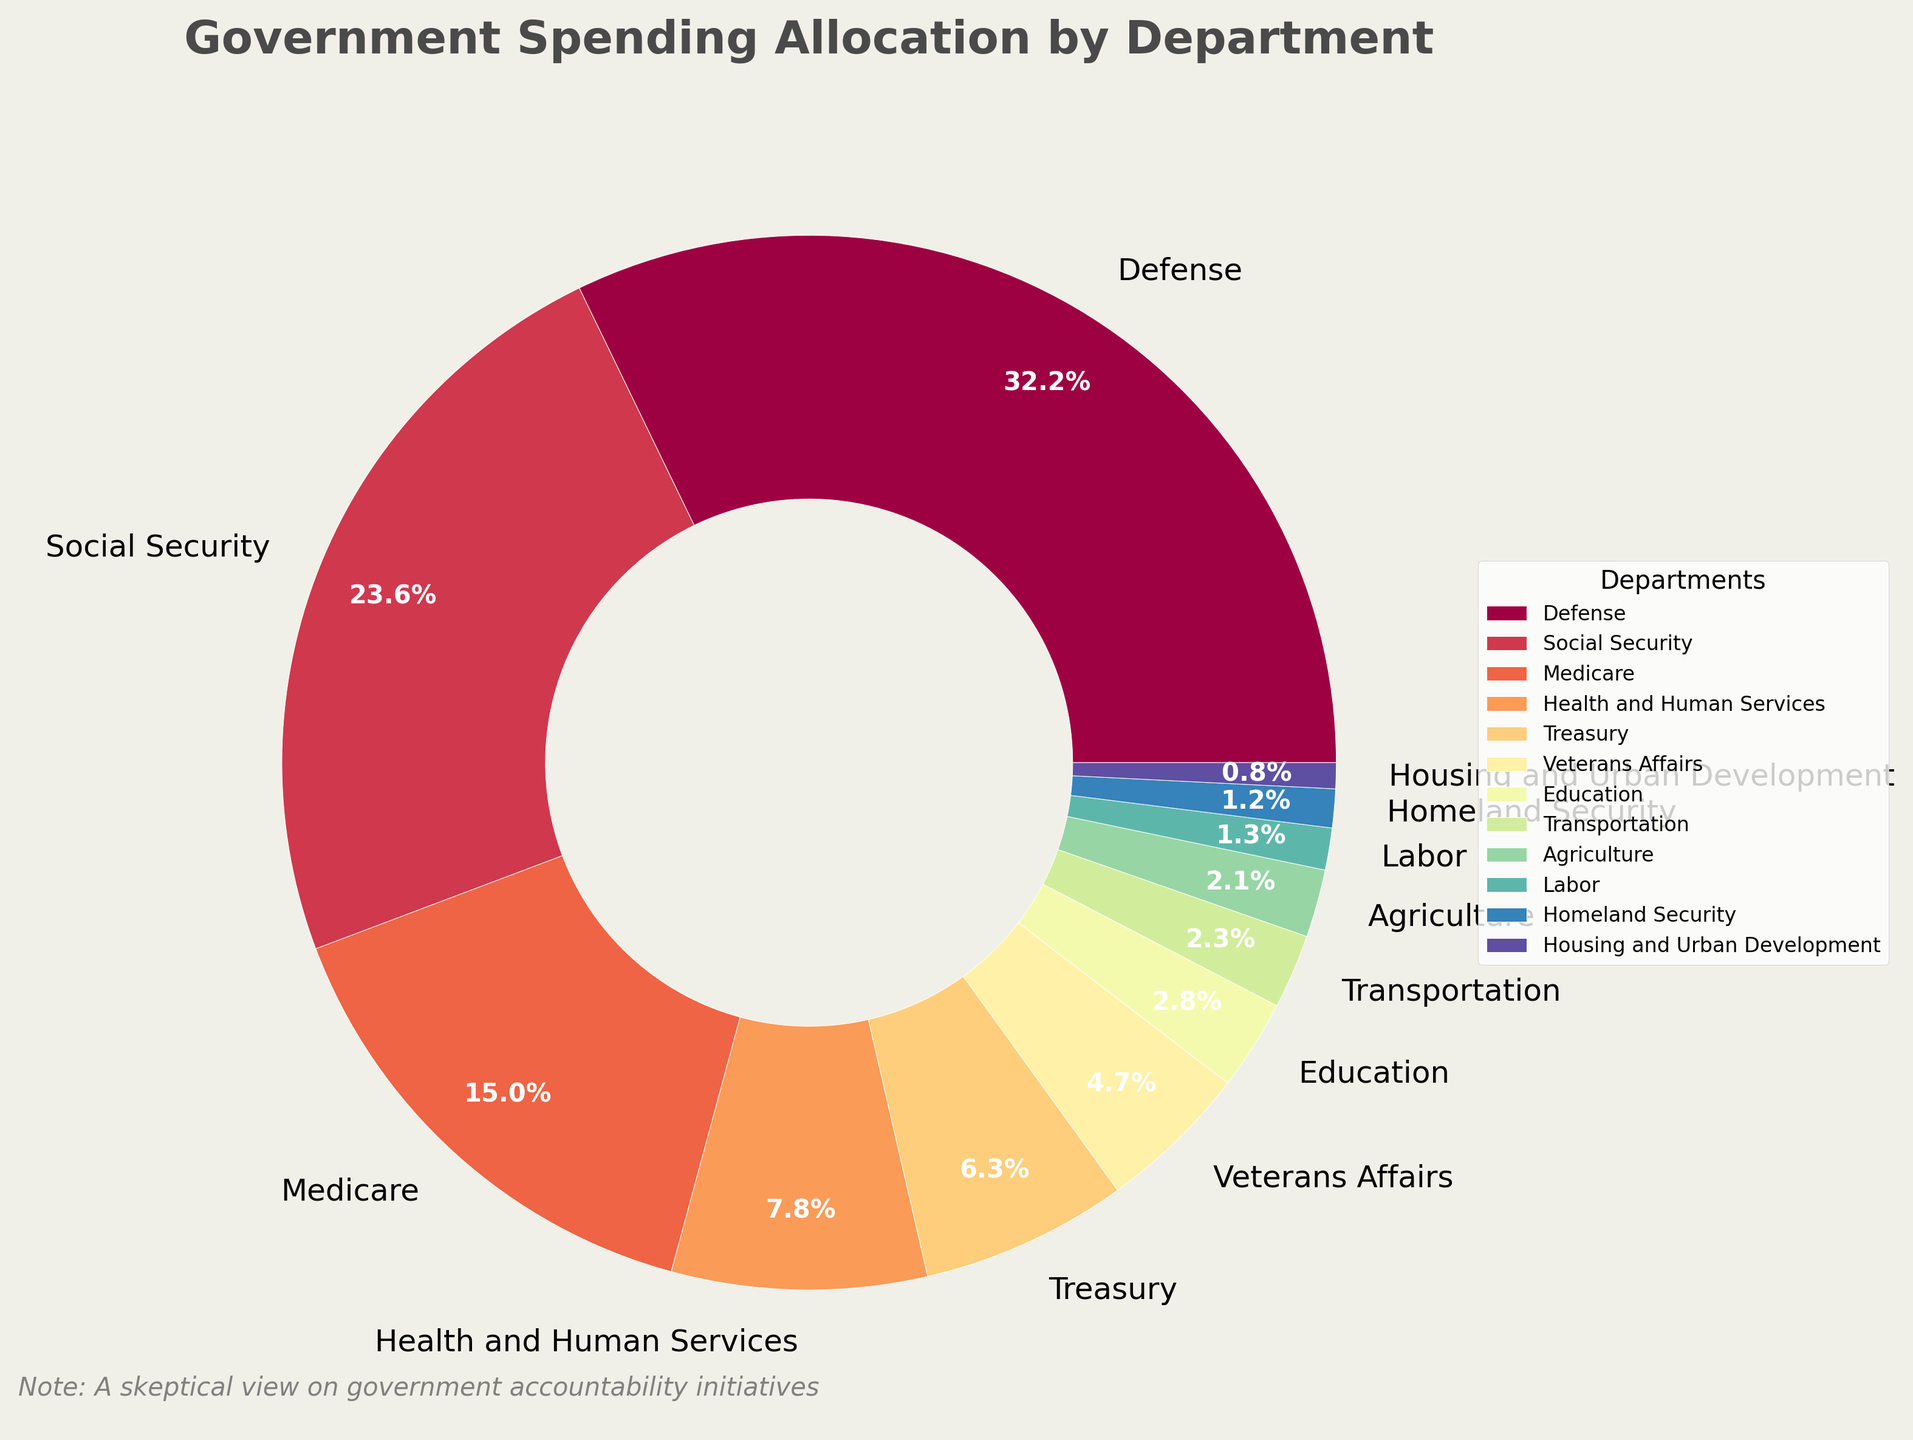Which department receives the largest percentage of government spending? Locate the segment of the pie chart with the largest area, which is labeled as "Defense" and marked with 32.5%.
Answer: Defense How much more is allocated to Social Security than to Transportation? Identify the percentages for Social Security (23.8%) and Transportation (2.3%). Calculate the difference: 23.8% - 2.3% = 21.5%.
Answer: 21.5% Is the percentage spending on Veterans Affairs higher or lower than that on the Treasury? Compare the percentages labeled for Veterans Affairs (4.7%) and the Treasury (6.4%). The percentage for Veterans Affairs is lower.
Answer: Lower What is the combined percentage of government spending on Medicare and Health and Human Services? Add the percentages of Medicare (15.2%) and Health and Human Services (7.9%): 15.2% + 7.9% = 23.1%.
Answer: 23.1% Are the combined allocations to Labor and Housing and Urban Development greater than the allocations to Education? Add the percentages for Labor (1.3%) and Housing and Urban Development (0.8%), then compare the sum to Education (2.8%): 1.3% + 0.8% = 2.1%, which is less than 2.8%.
Answer: No Which department receives the smallest percentage of government spending? Identify the segment of the pie chart with the smallest area, labeled as "Housing and Urban Development" with 0.8%.
Answer: Housing and Urban Development What percentage more is allocated to Medicare compared to Agriculture? Find the percentages for Medicare (15.2%) and Agriculture (2.1%). Calculate the difference: 15.2% - 2.1% = 13.1%.
Answer: 13.1% Are the allocations to Health and Human Services and the Treasury more than those to Education and Transportation combined? Add the percentages for Health and Human Services (7.9%) and the Treasury (6.4%), then compare the sum to the combined total of Education (2.8%) and Transportation (2.3%): 7.9% + 6.4% = 14.3%; 2.8% + 2.3% = 5.1%. Since 14.3% > 5.1%, the answer is yes.
Answer: Yes What is the percentage difference between the Defense and Medicare allocations? Subtract the percentage of Medicare (15.2%) from Defense (32.5%): 32.5% - 15.2% = 17.3%.
Answer: 17.3% Which departments have spending allocations greater than 10%? Identify and list the departments from the pie chart with percentages greater than 10%, which are Defense (32.5%), Social Security (23.8%), and Medicare (15.2%).
Answer: Defense, Social Security, Medicare 